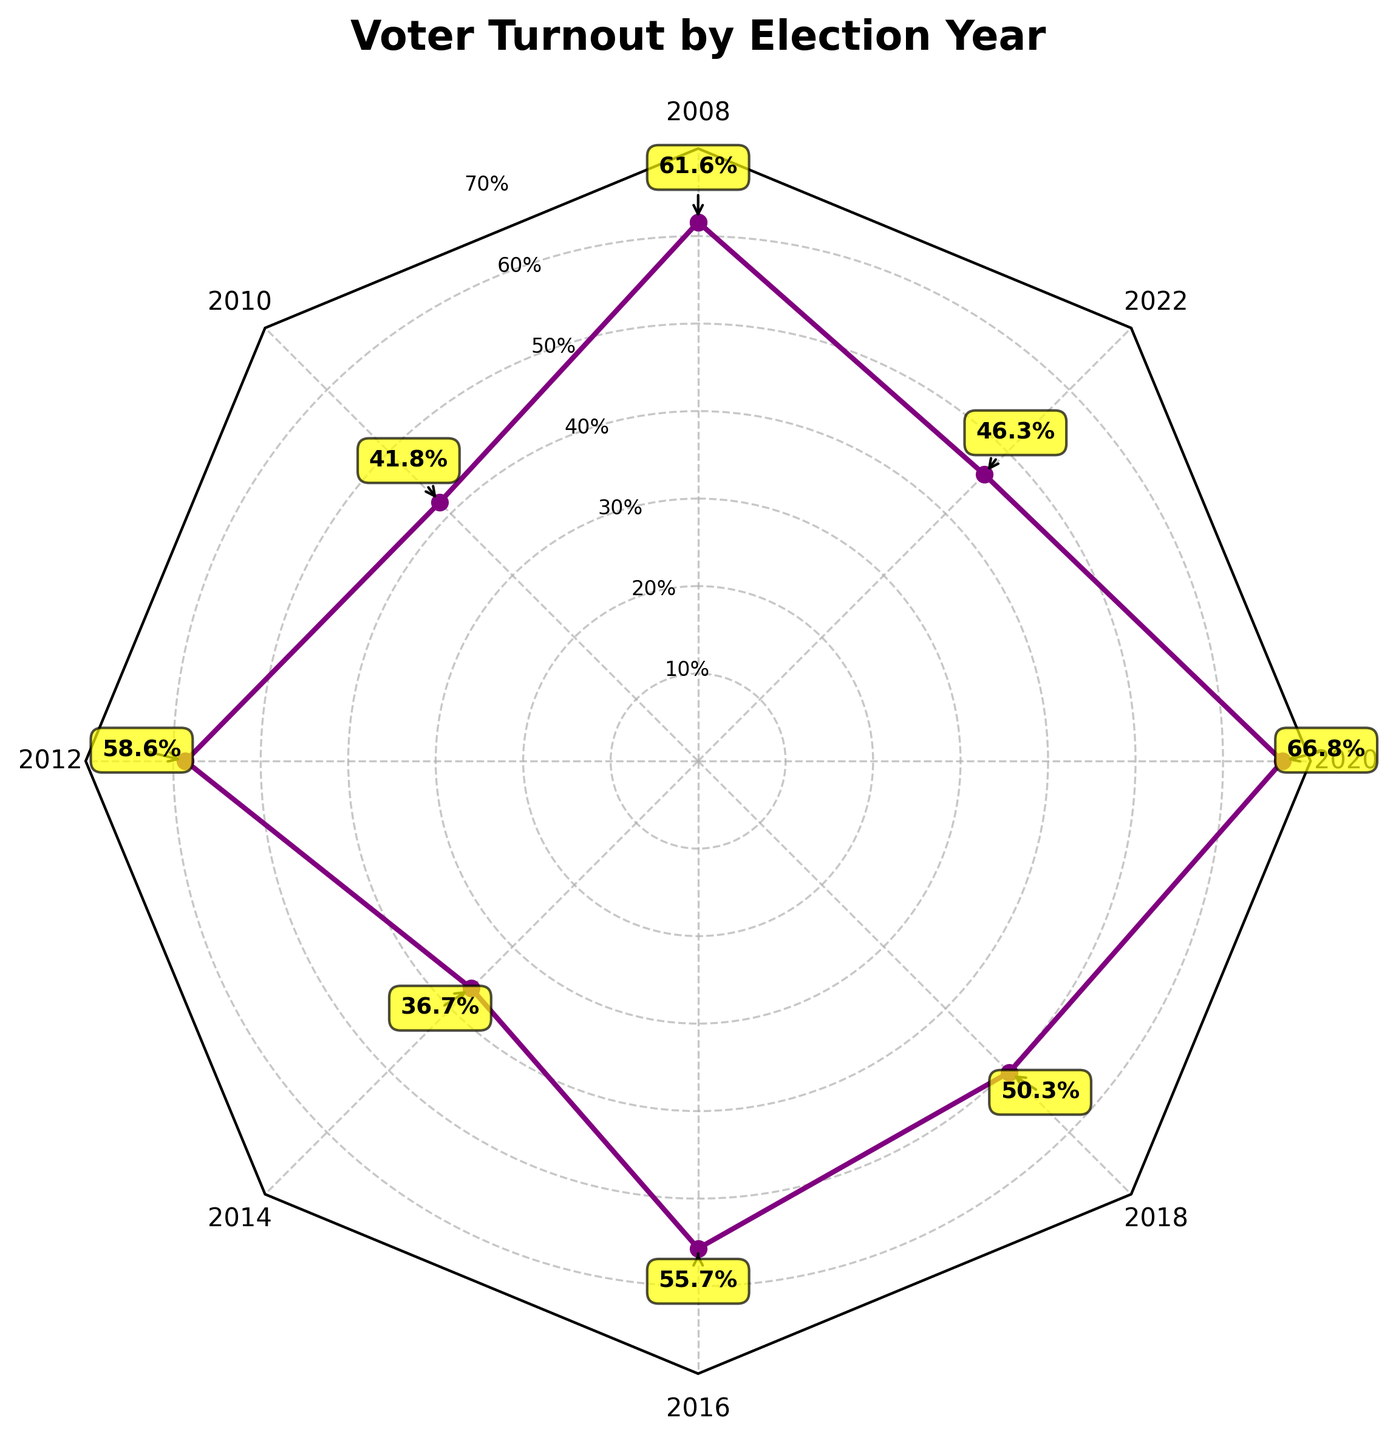What is the highest voter turnout recorded in the data? The highest voter turnout can be found by looking at the plot where the data point reaches the highest value on the radial axis. The highest value is marked near the outer edge of the radar chart.
Answer: 66.8% What year corresponds to the lowest voter turnout? By identifying the data point closest to the center of the radar chart, you can determine the year associated with the lowest voter turnout. The center-most data point appears around the year 2014.
Answer: 2014 Which healthcare policy had the most significant voter turnout impact, judging by the highest voter turnout? Find the policy associated with the year that had the highest voter turnout. The year 2020 had the highest turnout, related to policies on COVID-19 Response and ACA Strengthening.
Answer: COVID-19 Response and ACA Strengthening What is the average voter turnout percentage over the years provided? Sum the voter turnout percentages for all years and divide by the number of years. The sum of turnouts is 61.6 + 41.8 + 58.6 + 36.7 + 55.7 + 50.3 + 66.8 + 46.3 = 418.8. The number of years is 8. The average turnout is 418.8/8.
Answer: 52.35% How did voter turnout change from 2008 to 2012? Note the voter turnout percentages for 2008 and 2012 and calculate the difference. The turnout in 2008 was 61.6%, and in 2012 it was 58.6%. The change is 58.6 - 61.6.
Answer: -3% Compare the voter turnout between the elections associated with Democratic victories and Republican victories. Which had higher average turnout? Calculate and compare the average voter turnout for the years with Democratic victories (2008, 2012, 2018, 2020, 2022) and Republican victories (2010, 2014, 2016). Democratic: (61.6 + 58.6 + 50.3 + 66.8 + 46.3)/5 = 56.72%. Republican: (41.8 + 36.7 + 55.7)/3 = 44.73%.
Answer: Democratic Which election years had voter turnout rates above 50%? Identify the years where the radar chart data points are above the 50% radial marker. The years that have voter turnouts above 50% are 2008, 2012, 2016, and 2020.
Answer: 2008, 2012, 2016, 2020 Is there any observable trend in voter turnout over the years in relation to the healthcare policies introduced? Look at the overall shape and pattern of the radar chart to assess trends. Voter turnout seems to spike during significant healthcare policy implementations or major proposals, such as the ACA and COVID-19 response.
Answer: Yes, major policy changes Which year had a more significant impact on voter turnout: 2016 or 2018? Compare the data points for the years 2016 and 2018. The turnout for 2016 was 55.7%, while for 2018 it was 50.3%. Since 55.7% is higher, 2016 had a more significant impact.
Answer: 2016 